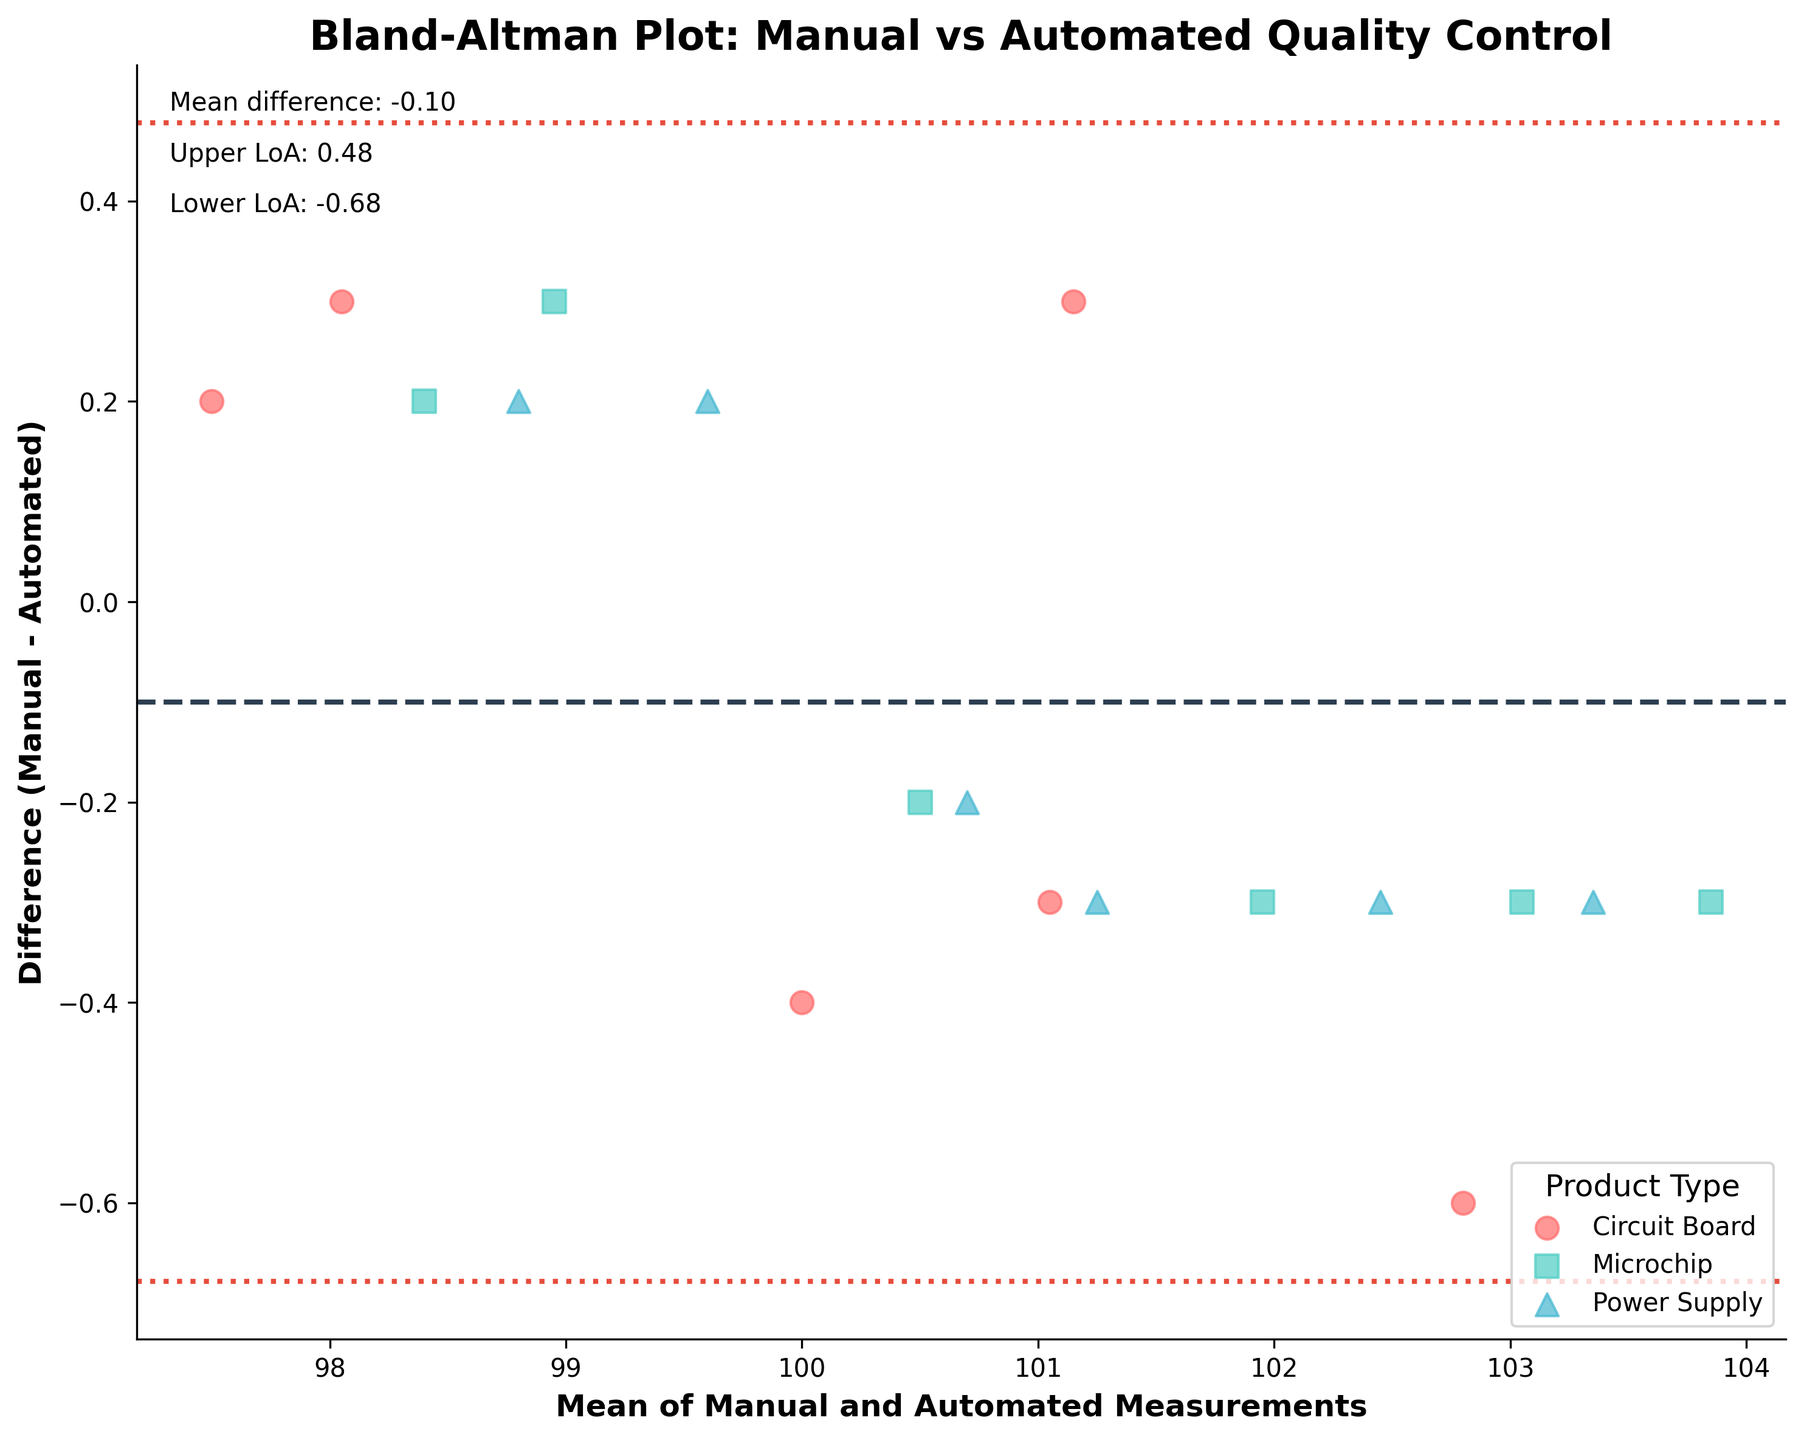What is the title of the plot? The title of the plot is written at the top of the figure.
Answer: Bland-Altman Plot: Manual vs Automated Quality Control What do the x-axis and y-axis represent? The x-axis label shows it represents the mean of manual and automated measurements while the y-axis label indicates it represents the difference between manual and automated measurements.
Answer: Mean of Manual and Automated Measurements; Difference (Manual - Automated) What is the mean difference between manual and automated measurements? The mean difference is indicated by the dashed horizontal line and also written as text on the figure.
Answer: Mean difference: 0.10 What are the upper and lower limits of agreement (LoA)? The upper limit of agreement (upper dashed line) and the lower limit of agreement (lower dashed line) are specified as text on the figure.
Answer: Upper LoA: 0.92; Lower LoA: -0.72 How many different product types are shown in the plot? There are three distinct colors and markers used in the plot, indicating three different product types.
Answer: Three (Circuit Board, Microchip, Power Supply) Which product type shows the largest variation in measurement differences? By examining the spread of points along the y-axis for each product type, Circuit Board shows the largest range of measurement differences.
Answer: Circuit Board Are there any points outside the limits of agreement? All points fall within the dashed lines representing the limits of agreement on the y-axis.
Answer: No Which product type has markers in the shape of squares? The legend shows that the Microchip product type is represented by square markers.
Answer: Microchip What is the color used for the Power Supply product type? The legend indicates that the Power Supply data points are colored light blue.
Answer: Light blue Between which two product types is the agreement closest to the mean difference? By comparing the spread of points around the mean difference line for each product type, both Microchip and Power Supply appear closest to the mean difference, but of these two, Power Supply shows measurements more closely clustered around the mean line with smaller variation.
Answer: Power Supply 